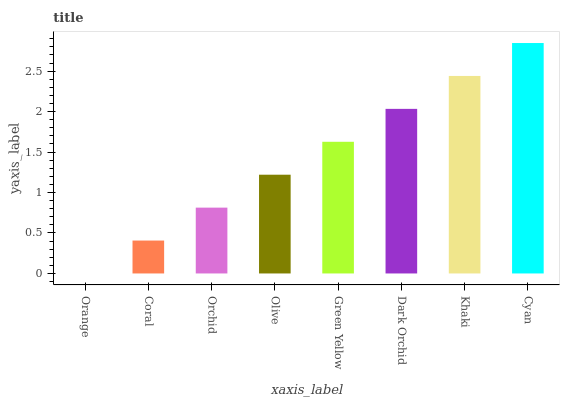Is Coral the minimum?
Answer yes or no. No. Is Coral the maximum?
Answer yes or no. No. Is Coral greater than Orange?
Answer yes or no. Yes. Is Orange less than Coral?
Answer yes or no. Yes. Is Orange greater than Coral?
Answer yes or no. No. Is Coral less than Orange?
Answer yes or no. No. Is Green Yellow the high median?
Answer yes or no. Yes. Is Olive the low median?
Answer yes or no. Yes. Is Khaki the high median?
Answer yes or no. No. Is Khaki the low median?
Answer yes or no. No. 